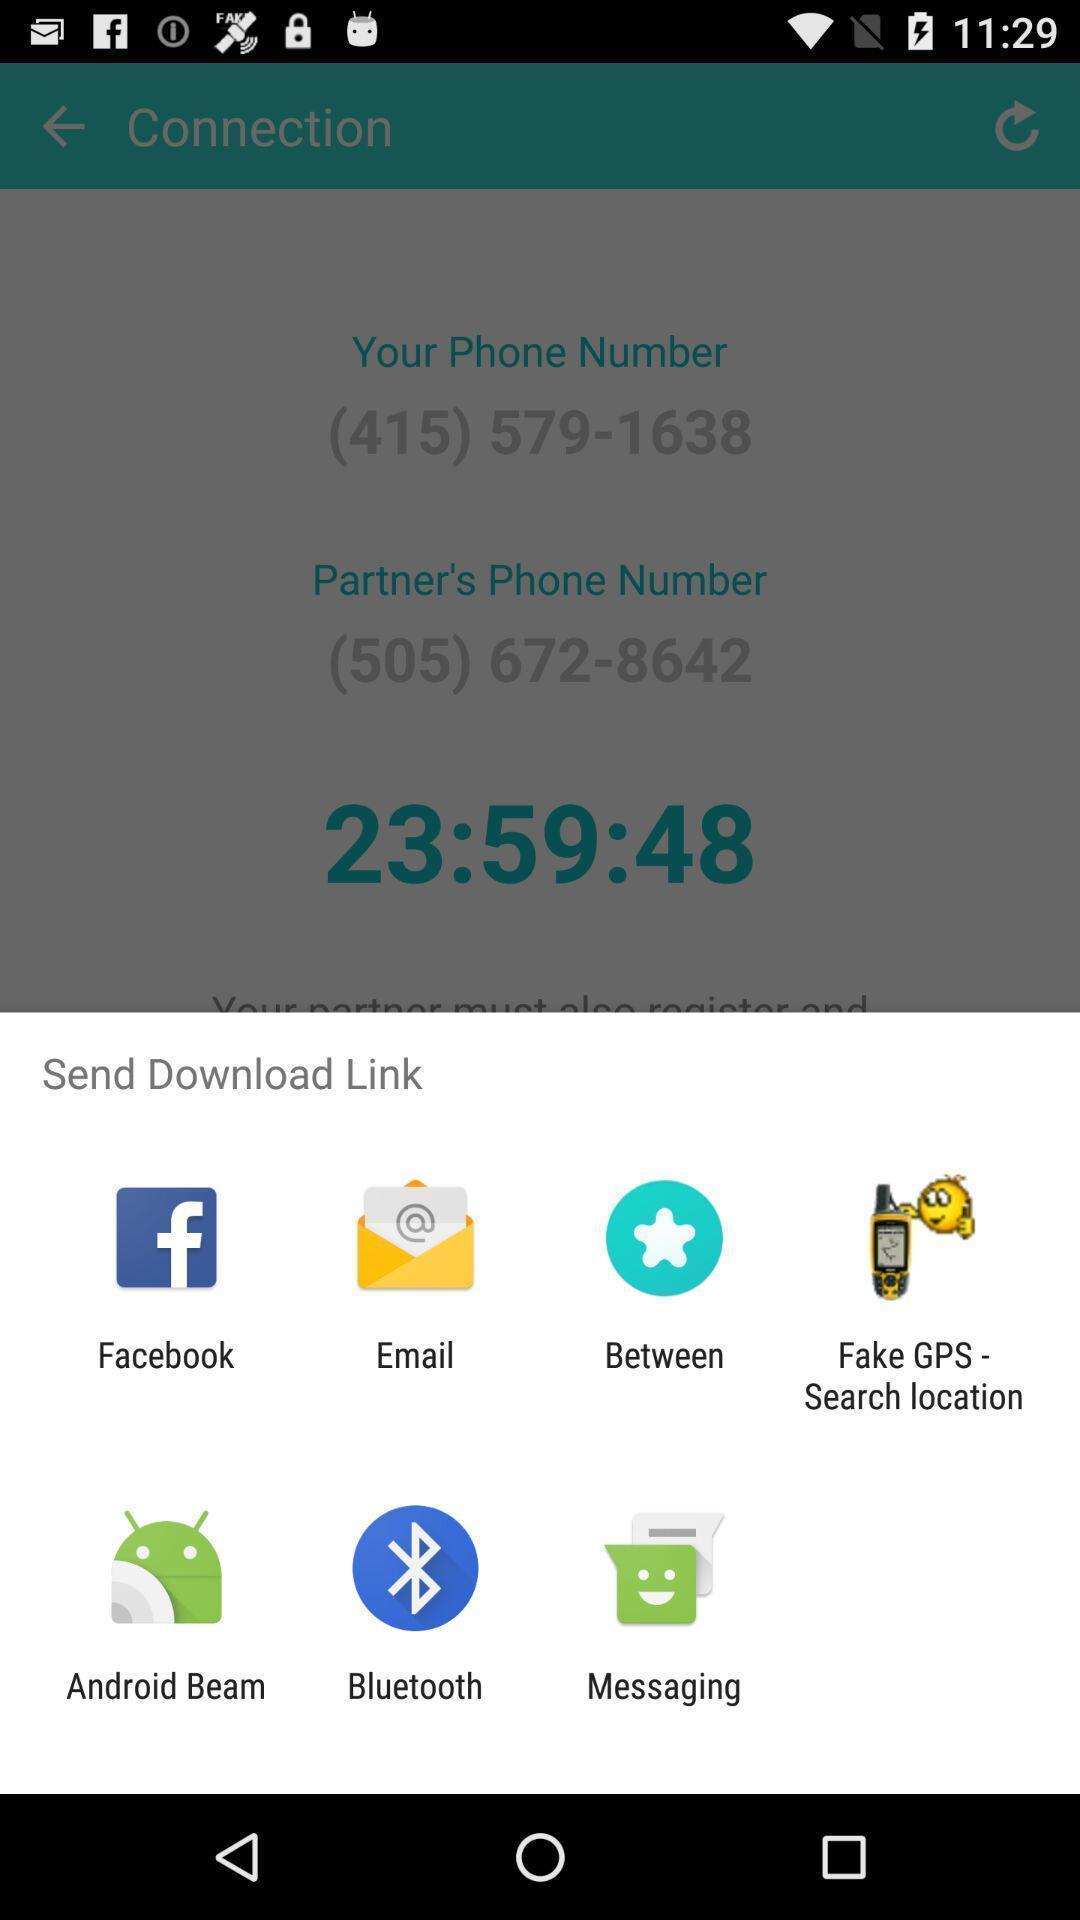Provide a description of this screenshot. Pop-up displaying multiple apps to send download link. 